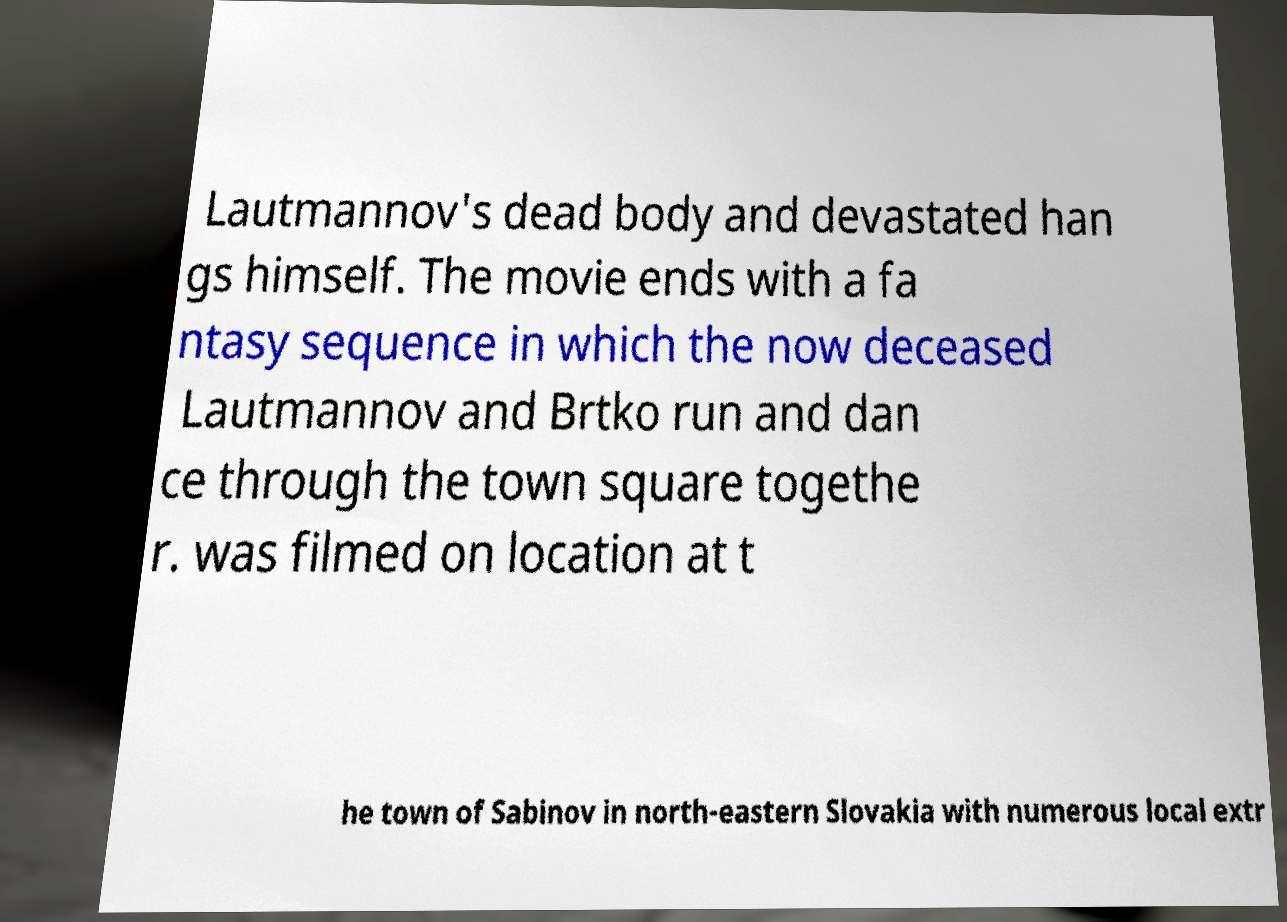Could you extract and type out the text from this image? Lautmannov's dead body and devastated han gs himself. The movie ends with a fa ntasy sequence in which the now deceased Lautmannov and Brtko run and dan ce through the town square togethe r. was filmed on location at t he town of Sabinov in north-eastern Slovakia with numerous local extr 